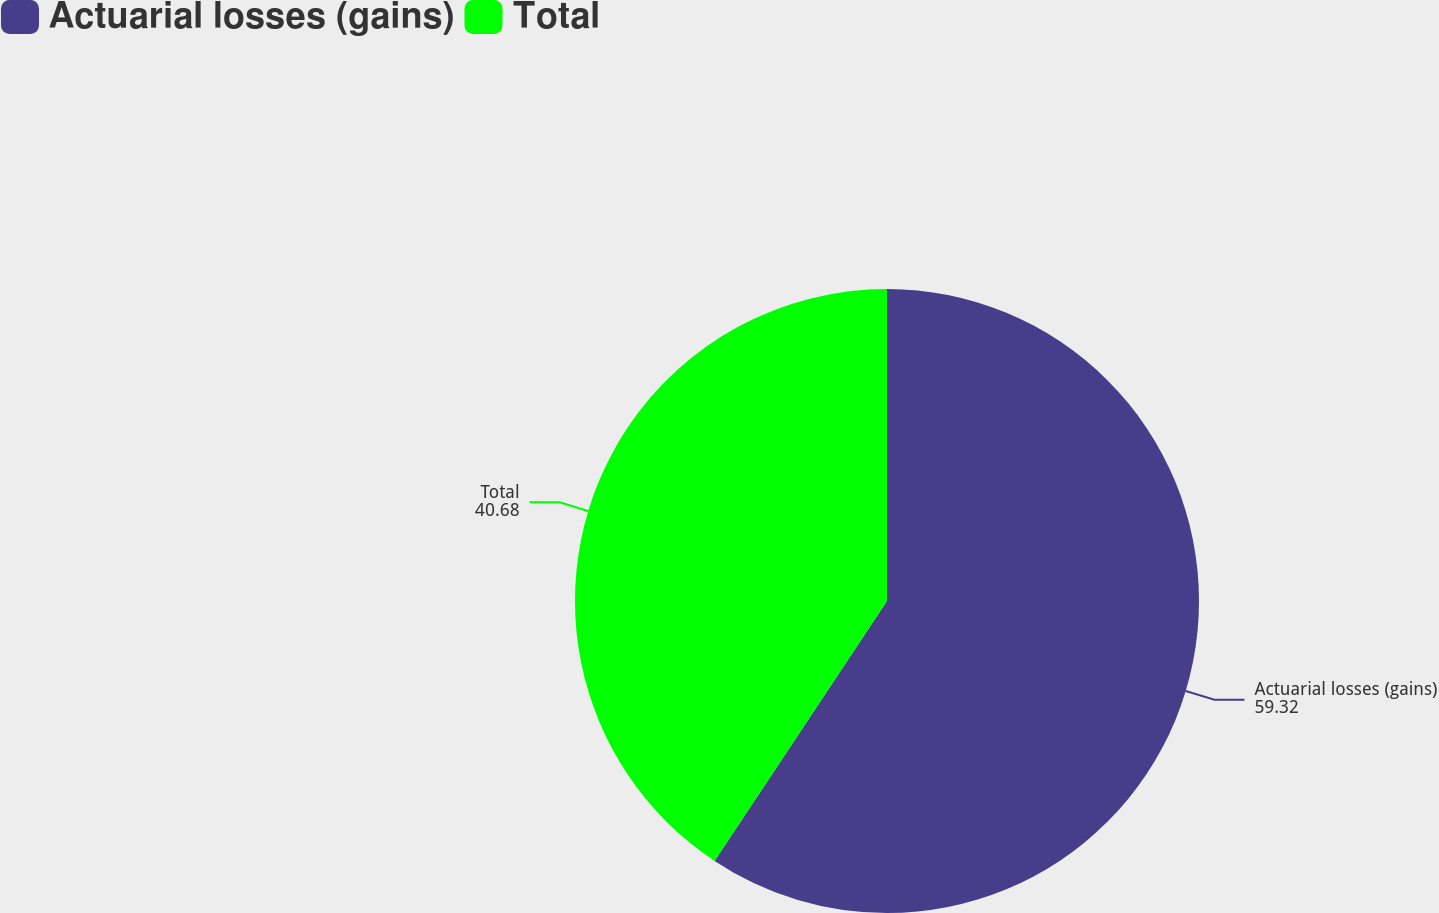<chart> <loc_0><loc_0><loc_500><loc_500><pie_chart><fcel>Actuarial losses (gains)<fcel>Total<nl><fcel>59.32%<fcel>40.68%<nl></chart> 